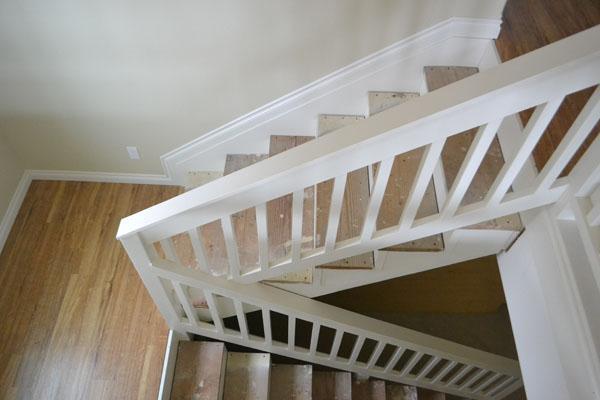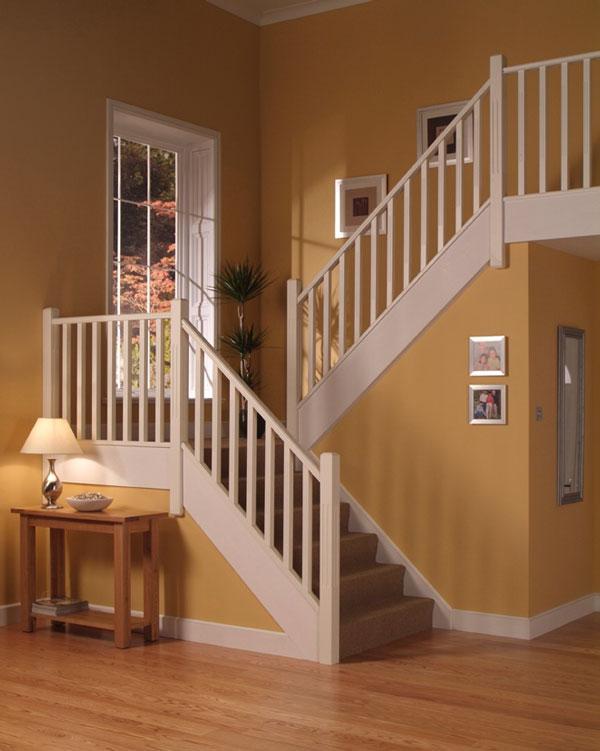The first image is the image on the left, the second image is the image on the right. Considering the images on both sides, is "Framed pictures line the stairway in one of the images." valid? Answer yes or no. Yes. The first image is the image on the left, the second image is the image on the right. For the images shown, is this caption "In at least one image there is a stair cause with dark colored trim and white rods." true? Answer yes or no. No. 